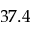<formula> <loc_0><loc_0><loc_500><loc_500>3 7 . 4</formula> 